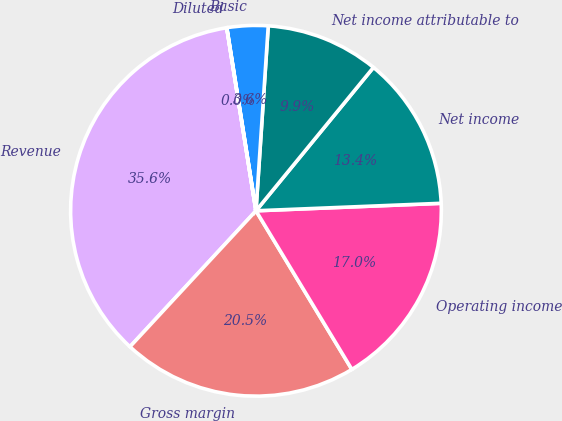<chart> <loc_0><loc_0><loc_500><loc_500><pie_chart><fcel>Revenue<fcel>Gross margin<fcel>Operating income<fcel>Net income<fcel>Net income attributable to<fcel>Basic<fcel>Diluted<nl><fcel>35.58%<fcel>20.55%<fcel>16.99%<fcel>13.43%<fcel>9.87%<fcel>3.57%<fcel>0.01%<nl></chart> 